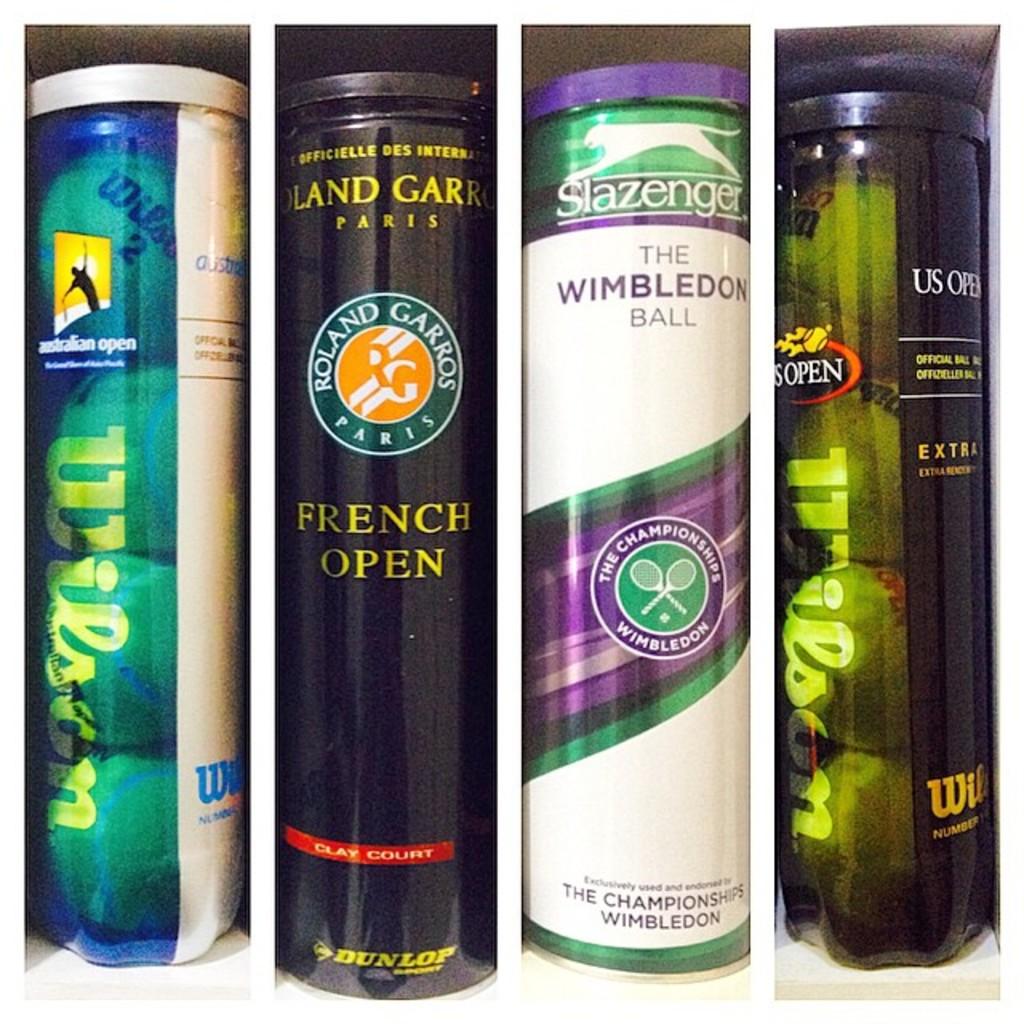What brand are these balls?
Make the answer very short. Wilson. Whatis the content in the bottles?
Your answer should be compact. Balls. 